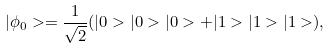Convert formula to latex. <formula><loc_0><loc_0><loc_500><loc_500>| \phi _ { 0 } > = \frac { 1 } { \sqrt { 2 } } ( | 0 > | 0 > | 0 > + | 1 > | 1 > | 1 > ) ,</formula> 